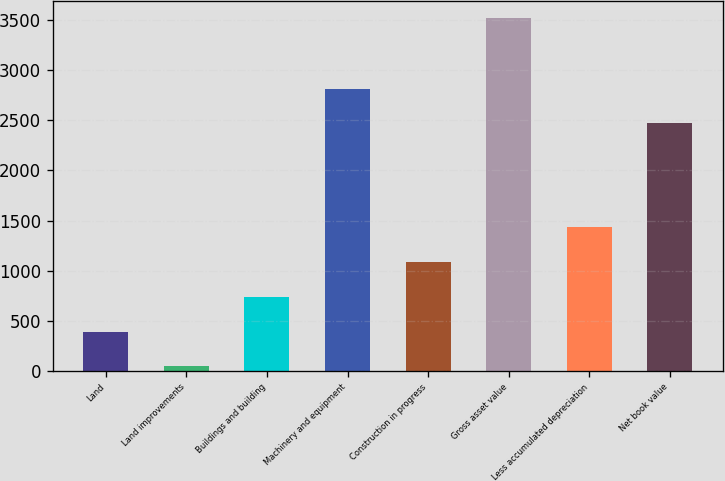<chart> <loc_0><loc_0><loc_500><loc_500><bar_chart><fcel>Land<fcel>Land improvements<fcel>Buildings and building<fcel>Machinery and equipment<fcel>Construction in progress<fcel>Gross asset value<fcel>Less accumulated depreciation<fcel>Net book value<nl><fcel>391.7<fcel>44<fcel>739.4<fcel>2817.7<fcel>1087.1<fcel>3521<fcel>1434.8<fcel>2470<nl></chart> 